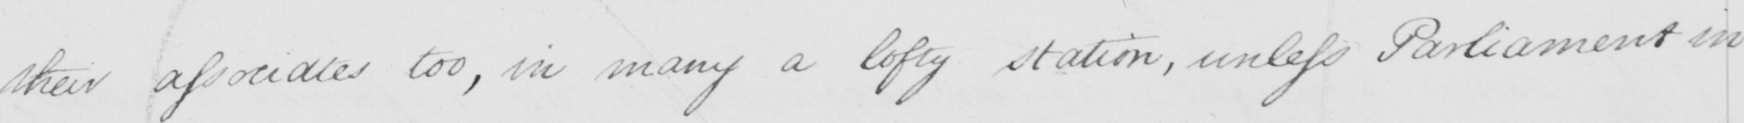Can you read and transcribe this handwriting? their associates too , in many a lofty station , unless Parliament in 